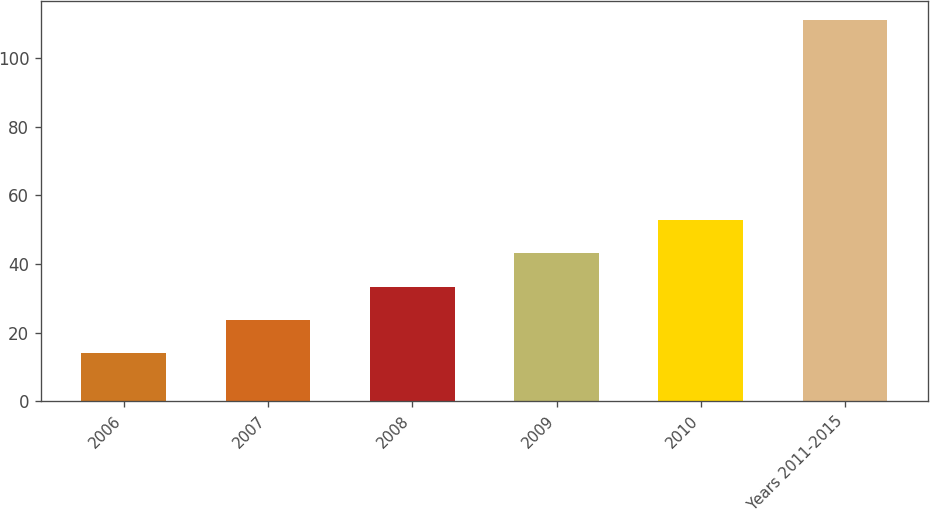Convert chart. <chart><loc_0><loc_0><loc_500><loc_500><bar_chart><fcel>2006<fcel>2007<fcel>2008<fcel>2009<fcel>2010<fcel>Years 2011-2015<nl><fcel>14<fcel>23.7<fcel>33.4<fcel>43.1<fcel>52.8<fcel>111<nl></chart> 